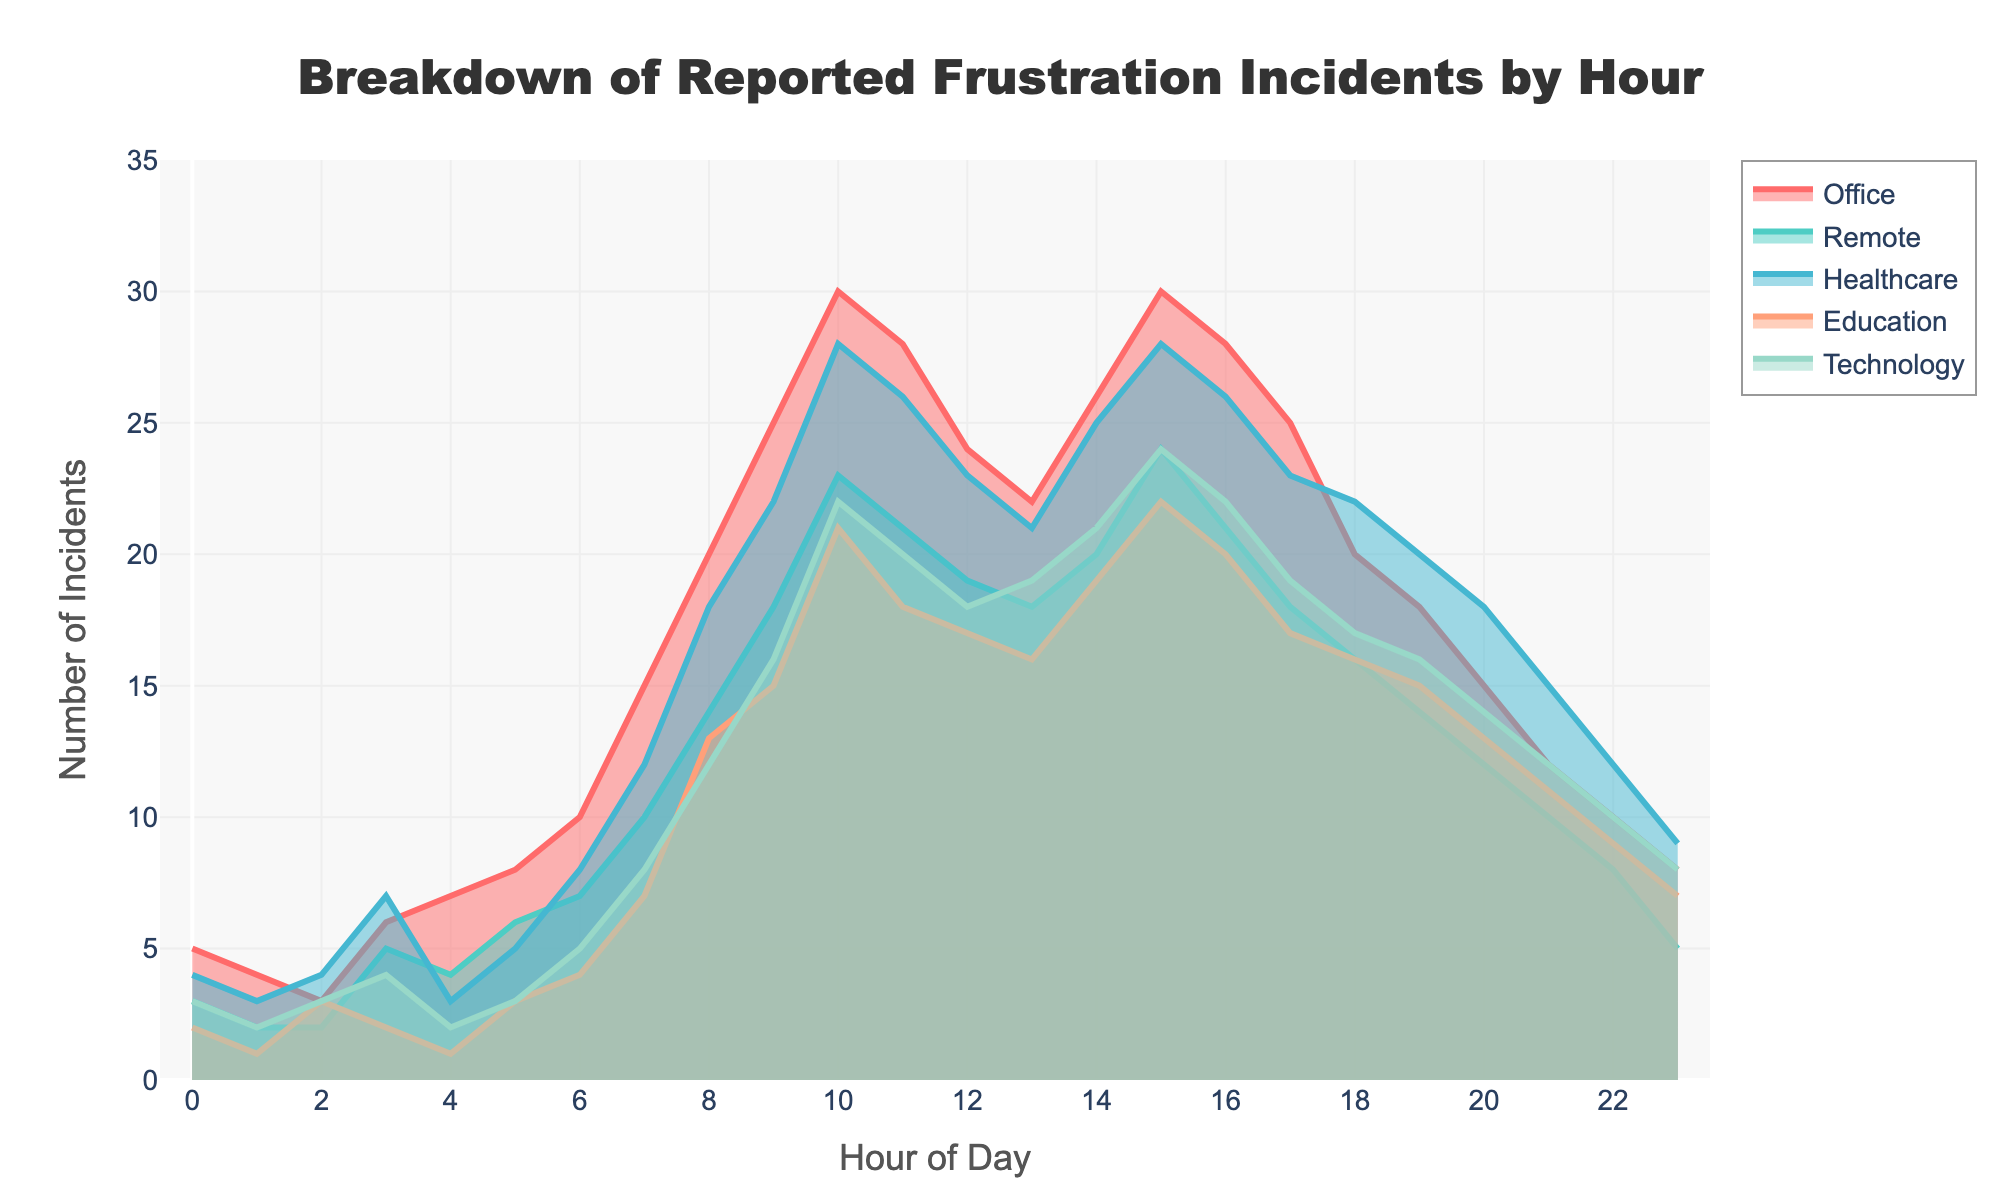What is the title of the plot? The title of the plot is typically located at the top of the figure, providing a succinct description of what the plot is about. It helps viewers understand the overall topic immediately.
Answer: Breakdown of Reported Frustration Incidents by Hour What is the highest number of frustration incidents reported in an Office environment, and at what hour does it occur? To find this, identify the peak value specifically for the Office category trace and note the corresponding hour on the x-axis.
Answer: 30 incidents at hour 10 and hour 15 At which hour is the lowest number of frustration incidents reported in the Technology sector? Look for the lowest data point along the Technology sector trace and identify the associated hour on the x-axis.
Answer: Hour 0 Compare the number of remote work frustration incidents reported at hour 9 with those reported at hour 18. Which hour has higher incidents, and by how much? Locate the values for the Remote category at hours 9 and 18, then calculate the difference to determine which is higher.
Answer: Hour 9 has higher incidents by 2 (18 at hour 9 and 16 at hour 18) Which environment shows the most significant increase in frustration incidents between hours 6 and 7? Examine the difference in reported incidents between hours 6 and 7 for each environment and identify which has the largest increase.
Answer: Technology (an increase from 5 to 8 incidents) Average frustration incidents in the Healthcare sector between hours 8 and 12 (inclusive). Sum the reported incidents in the Healthcare sector from hour 8 to hour 12 and divide by the number of hours in this interval (5 hours).
Answer: The average is (18+22+28+26+23)/5 = 23.4 Which sector reports more incidents at hour 20: Healthcare or Education, and by how much? Compare the number of incidents at hour 20 for both Healthcare and Education categories and calculate the difference.
Answer: Healthcare reports more by 5 incidents (Healthcare: 18, Education: 13) What trend is observed in the Education sector during the first 3 hours of the day? Look at the data points for the Education sector from hour 0 to hour 3 and describe the general direction of change.
Answer: Decreasing trend from 2 to 1 to 3 to 2 incidents Calculate the total number of frustration incidents reported across all environments at hour 9. Sum up the values from all categories (Office, Remote, Healthcare, Education, Technology) at hour 9 to get the total.
Answer: Total is 25 + 18 + 22 + 15 + 16 = 96 